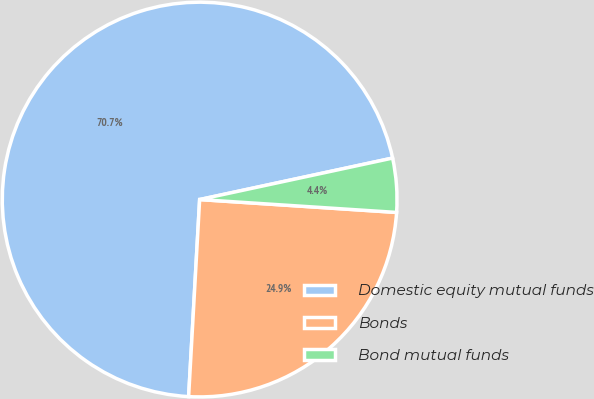Convert chart to OTSL. <chart><loc_0><loc_0><loc_500><loc_500><pie_chart><fcel>Domestic equity mutual funds<fcel>Bonds<fcel>Bond mutual funds<nl><fcel>70.74%<fcel>24.85%<fcel>4.41%<nl></chart> 